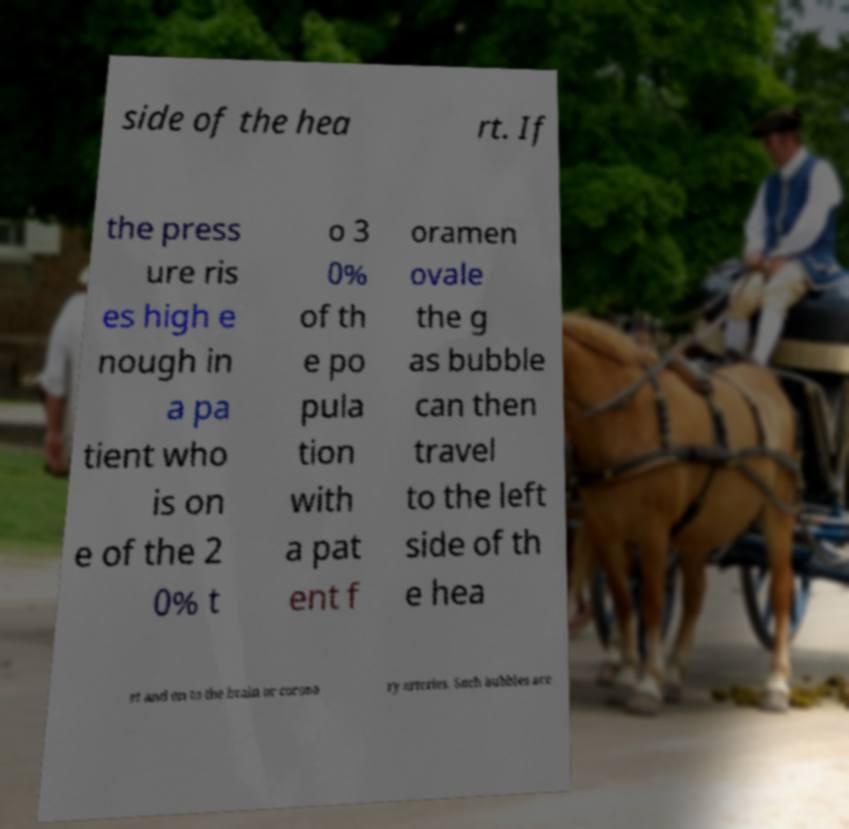Can you accurately transcribe the text from the provided image for me? side of the hea rt. If the press ure ris es high e nough in a pa tient who is on e of the 2 0% t o 3 0% of th e po pula tion with a pat ent f oramen ovale the g as bubble can then travel to the left side of th e hea rt and on to the brain or corona ry arteries. Such bubbles are 